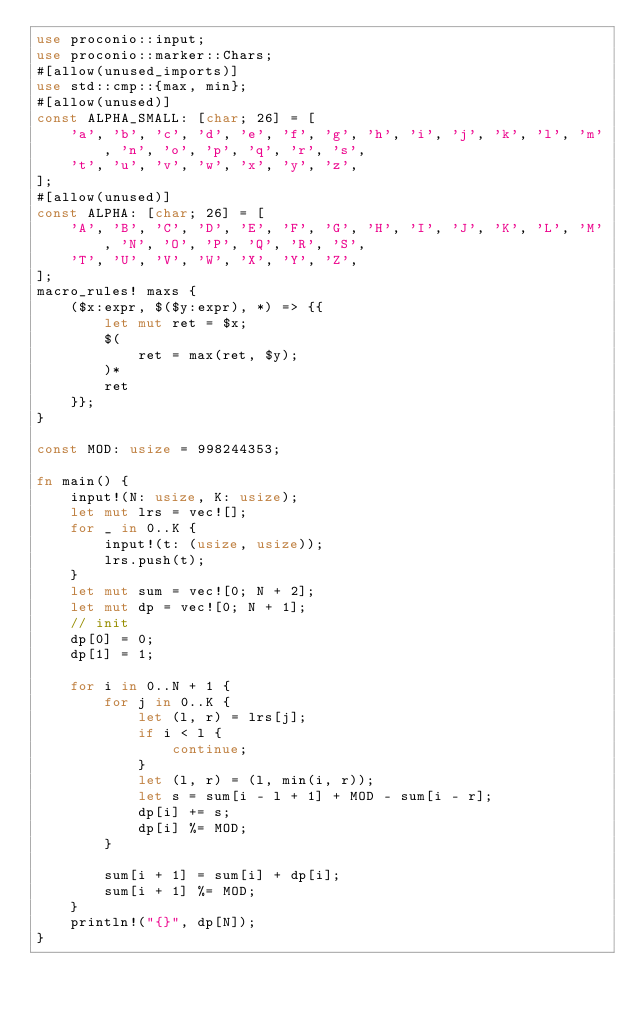<code> <loc_0><loc_0><loc_500><loc_500><_Rust_>use proconio::input;
use proconio::marker::Chars;
#[allow(unused_imports)]
use std::cmp::{max, min};
#[allow(unused)]
const ALPHA_SMALL: [char; 26] = [
    'a', 'b', 'c', 'd', 'e', 'f', 'g', 'h', 'i', 'j', 'k', 'l', 'm', 'n', 'o', 'p', 'q', 'r', 's',
    't', 'u', 'v', 'w', 'x', 'y', 'z',
];
#[allow(unused)]
const ALPHA: [char; 26] = [
    'A', 'B', 'C', 'D', 'E', 'F', 'G', 'H', 'I', 'J', 'K', 'L', 'M', 'N', 'O', 'P', 'Q', 'R', 'S',
    'T', 'U', 'V', 'W', 'X', 'Y', 'Z',
];
macro_rules! maxs {
    ($x:expr, $($y:expr), *) => {{
        let mut ret = $x;
        $(
            ret = max(ret, $y);
        )*
        ret
    }};
}

const MOD: usize = 998244353;

fn main() {
    input!(N: usize, K: usize);
    let mut lrs = vec![];
    for _ in 0..K {
        input!(t: (usize, usize));
        lrs.push(t);
    }
    let mut sum = vec![0; N + 2];
    let mut dp = vec![0; N + 1];
    // init
    dp[0] = 0;
    dp[1] = 1;

    for i in 0..N + 1 {
        for j in 0..K {
            let (l, r) = lrs[j];
            if i < l {
                continue;
            }
            let (l, r) = (l, min(i, r));
            let s = sum[i - l + 1] + MOD - sum[i - r];
            dp[i] += s;
            dp[i] %= MOD;
        }

        sum[i + 1] = sum[i] + dp[i];
        sum[i + 1] %= MOD;
    }
    println!("{}", dp[N]);
}
</code> 